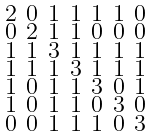Convert formula to latex. <formula><loc_0><loc_0><loc_500><loc_500>\begin{smallmatrix} 2 & 0 & 1 & 1 & 1 & 1 & 0 \\ 0 & 2 & 1 & 1 & 0 & 0 & 0 \\ 1 & 1 & 3 & 1 & 1 & 1 & 1 \\ 1 & 1 & 1 & 3 & 1 & 1 & 1 \\ 1 & 0 & 1 & 1 & 3 & 0 & 1 \\ 1 & 0 & 1 & 1 & 0 & 3 & 0 \\ 0 & 0 & 1 & 1 & 1 & 0 & 3 \end{smallmatrix}</formula> 